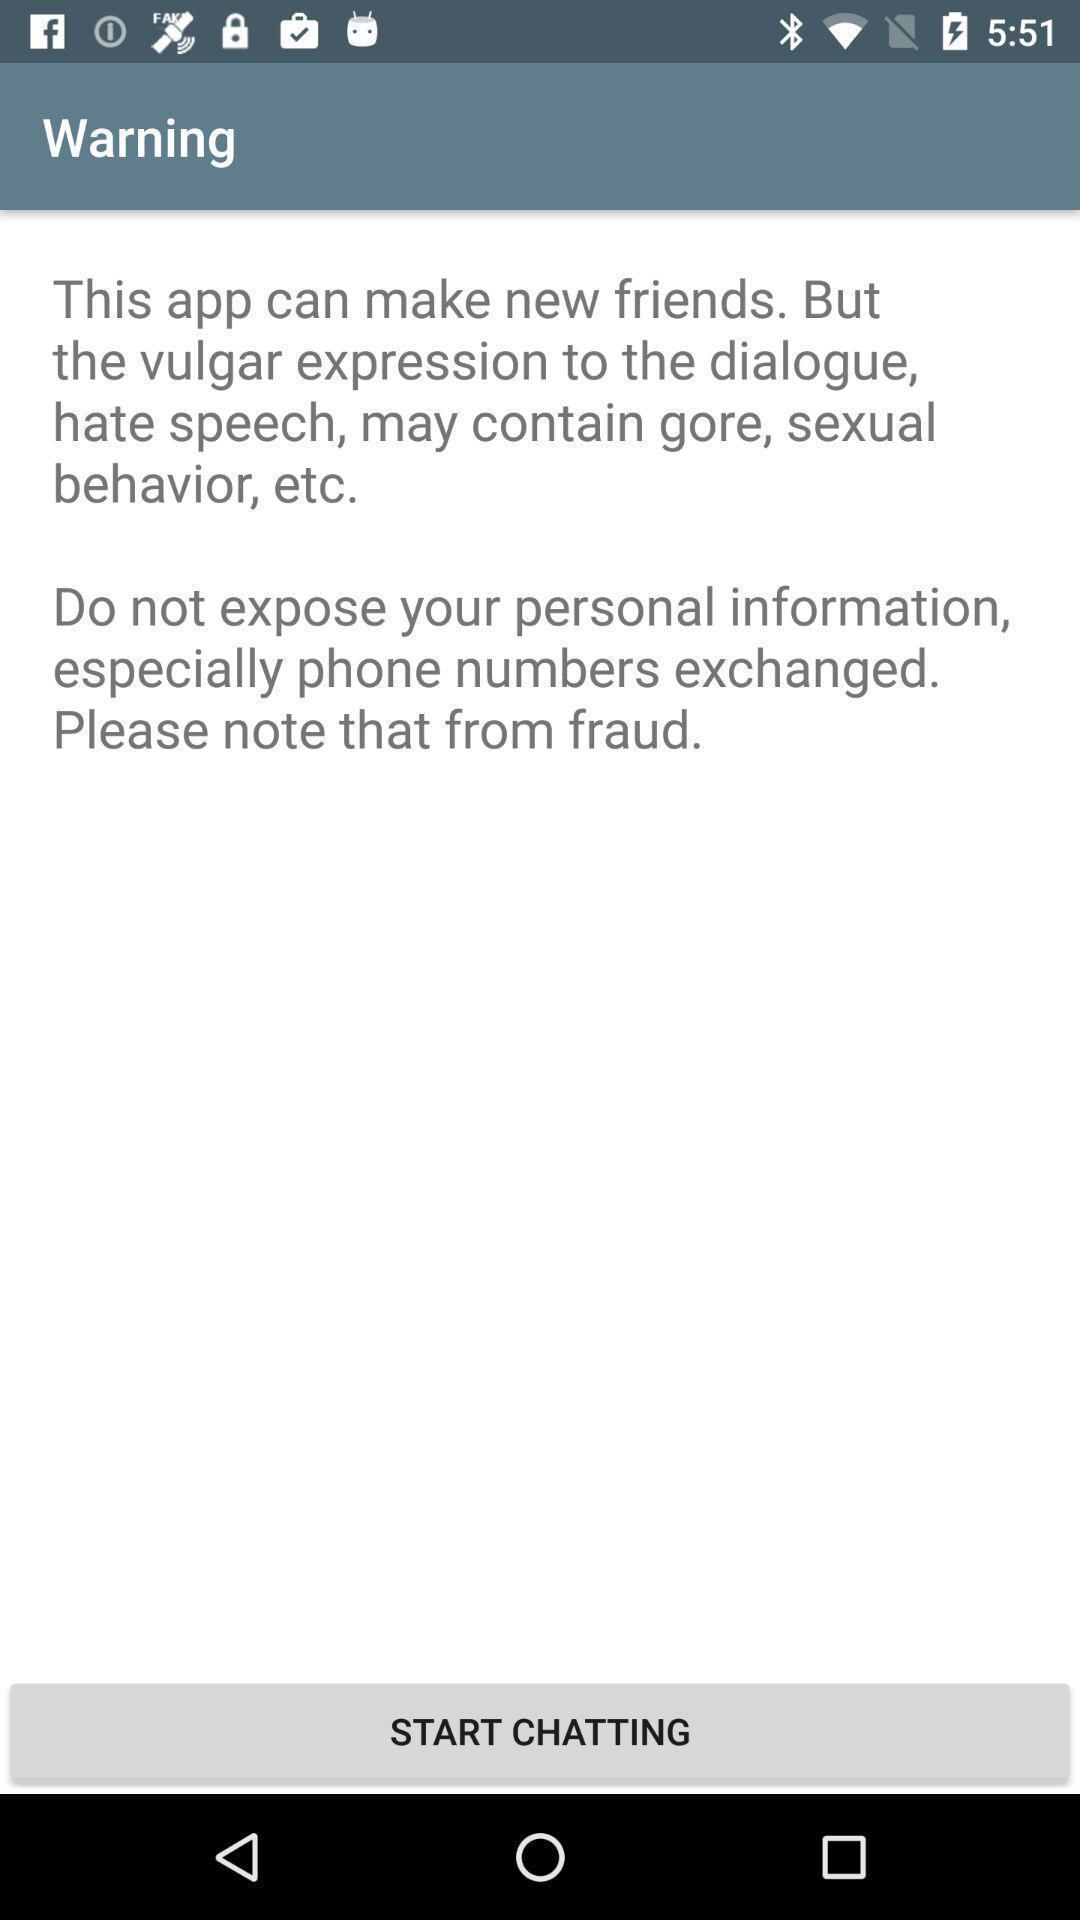Provide a detailed account of this screenshot. Screen displaying an alert message in a chatting application. 